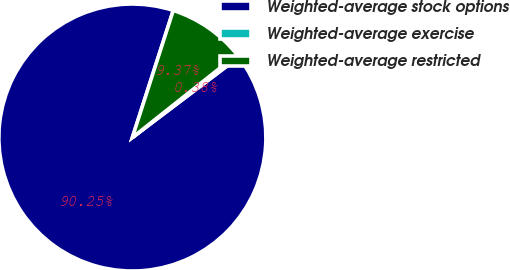Convert chart. <chart><loc_0><loc_0><loc_500><loc_500><pie_chart><fcel>Weighted-average stock options<fcel>Weighted-average exercise<fcel>Weighted-average restricted<nl><fcel>90.26%<fcel>0.38%<fcel>9.37%<nl></chart> 